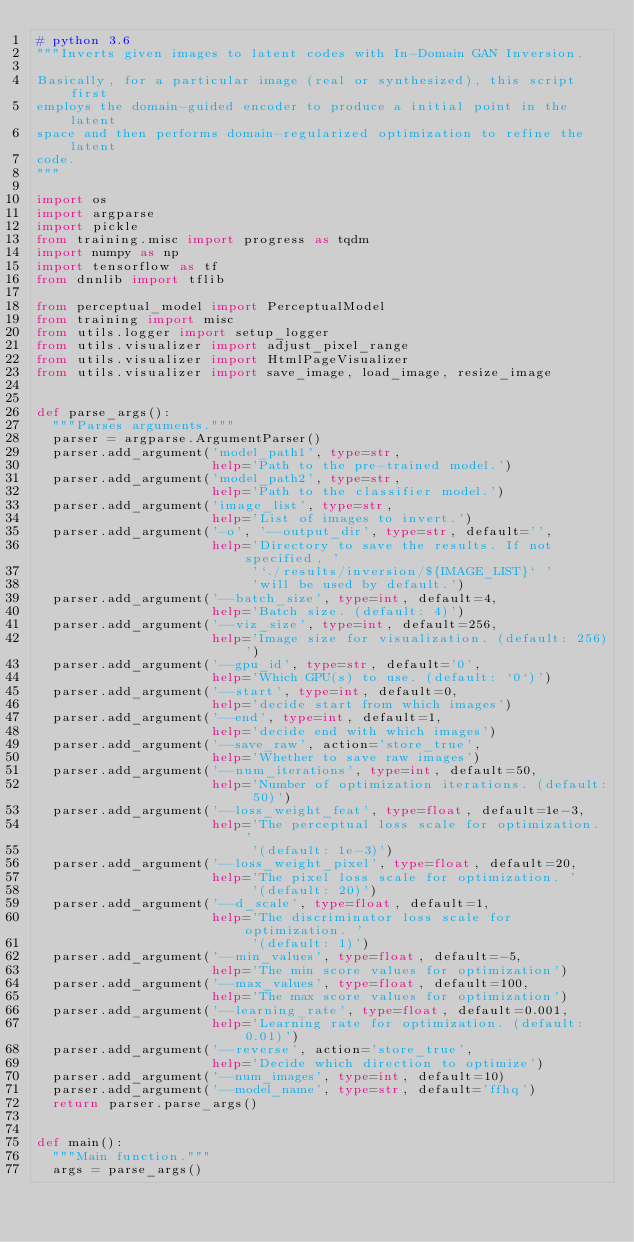Convert code to text. <code><loc_0><loc_0><loc_500><loc_500><_Python_># python 3.6
"""Inverts given images to latent codes with In-Domain GAN Inversion.

Basically, for a particular image (real or synthesized), this script first
employs the domain-guided encoder to produce a initial point in the latent
space and then performs domain-regularized optimization to refine the latent
code.
"""

import os
import argparse
import pickle
from training.misc import progress as tqdm
import numpy as np
import tensorflow as tf
from dnnlib import tflib

from perceptual_model import PerceptualModel
from training import misc
from utils.logger import setup_logger
from utils.visualizer import adjust_pixel_range
from utils.visualizer import HtmlPageVisualizer
from utils.visualizer import save_image, load_image, resize_image


def parse_args():
  """Parses arguments."""
  parser = argparse.ArgumentParser()
  parser.add_argument('model_path1', type=str,
                      help='Path to the pre-trained model.')
  parser.add_argument('model_path2', type=str,
                      help='Path to the classifier model.')
  parser.add_argument('image_list', type=str,
                      help='List of images to invert.')
  parser.add_argument('-o', '--output_dir', type=str, default='',
                      help='Directory to save the results. If not specified, '
                           '`./results/inversion/${IMAGE_LIST}` '
                           'will be used by default.')
  parser.add_argument('--batch_size', type=int, default=4,
                      help='Batch size. (default: 4)')
  parser.add_argument('--viz_size', type=int, default=256,
                      help='Image size for visualization. (default: 256)')
  parser.add_argument('--gpu_id', type=str, default='0',
                      help='Which GPU(s) to use. (default: `0`)')
  parser.add_argument('--start', type=int, default=0,
                      help='decide start from which images')
  parser.add_argument('--end', type=int, default=1,
                      help='decide end with which images')
  parser.add_argument('--save_raw', action='store_true',
                      help='Whether to save raw images')
  parser.add_argument('--num_iterations', type=int, default=50,
                      help='Number of optimization iterations. (default: 50)')
  parser.add_argument('--loss_weight_feat', type=float, default=1e-3,
                      help='The perceptual loss scale for optimization. '
                           '(default: 1e-3)')
  parser.add_argument('--loss_weight_pixel', type=float, default=20,
                      help='The pixel loss scale for optimization. '
                           '(default: 20)')
  parser.add_argument('--d_scale', type=float, default=1,
                      help='The discriminator loss scale for optimization. '
                           '(default: 1)')
  parser.add_argument('--min_values', type=float, default=-5,
                      help='The min score values for optimization')
  parser.add_argument('--max_values', type=float, default=100,
                      help='The max score values for optimization')
  parser.add_argument('--learning_rate', type=float, default=0.001,
                      help='Learning rate for optimization. (default: 0.01)')
  parser.add_argument('--reverse', action='store_true',
                      help='Decide which direction to optimize')
  parser.add_argument('--num_images', type=int, default=10)
  parser.add_argument('--model_name', type=str, default='ffhq')
  return parser.parse_args()


def main():
  """Main function."""
  args = parse_args()</code> 